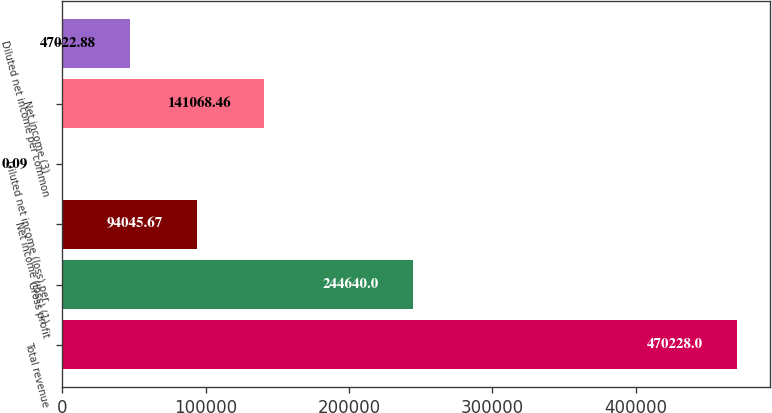Convert chart. <chart><loc_0><loc_0><loc_500><loc_500><bar_chart><fcel>Total revenue<fcel>Gross profit<fcel>Net income (loss) (1)<fcel>Diluted net income (loss) per<fcel>Net income (3)<fcel>Diluted net income per common<nl><fcel>470228<fcel>244640<fcel>94045.7<fcel>0.09<fcel>141068<fcel>47022.9<nl></chart> 